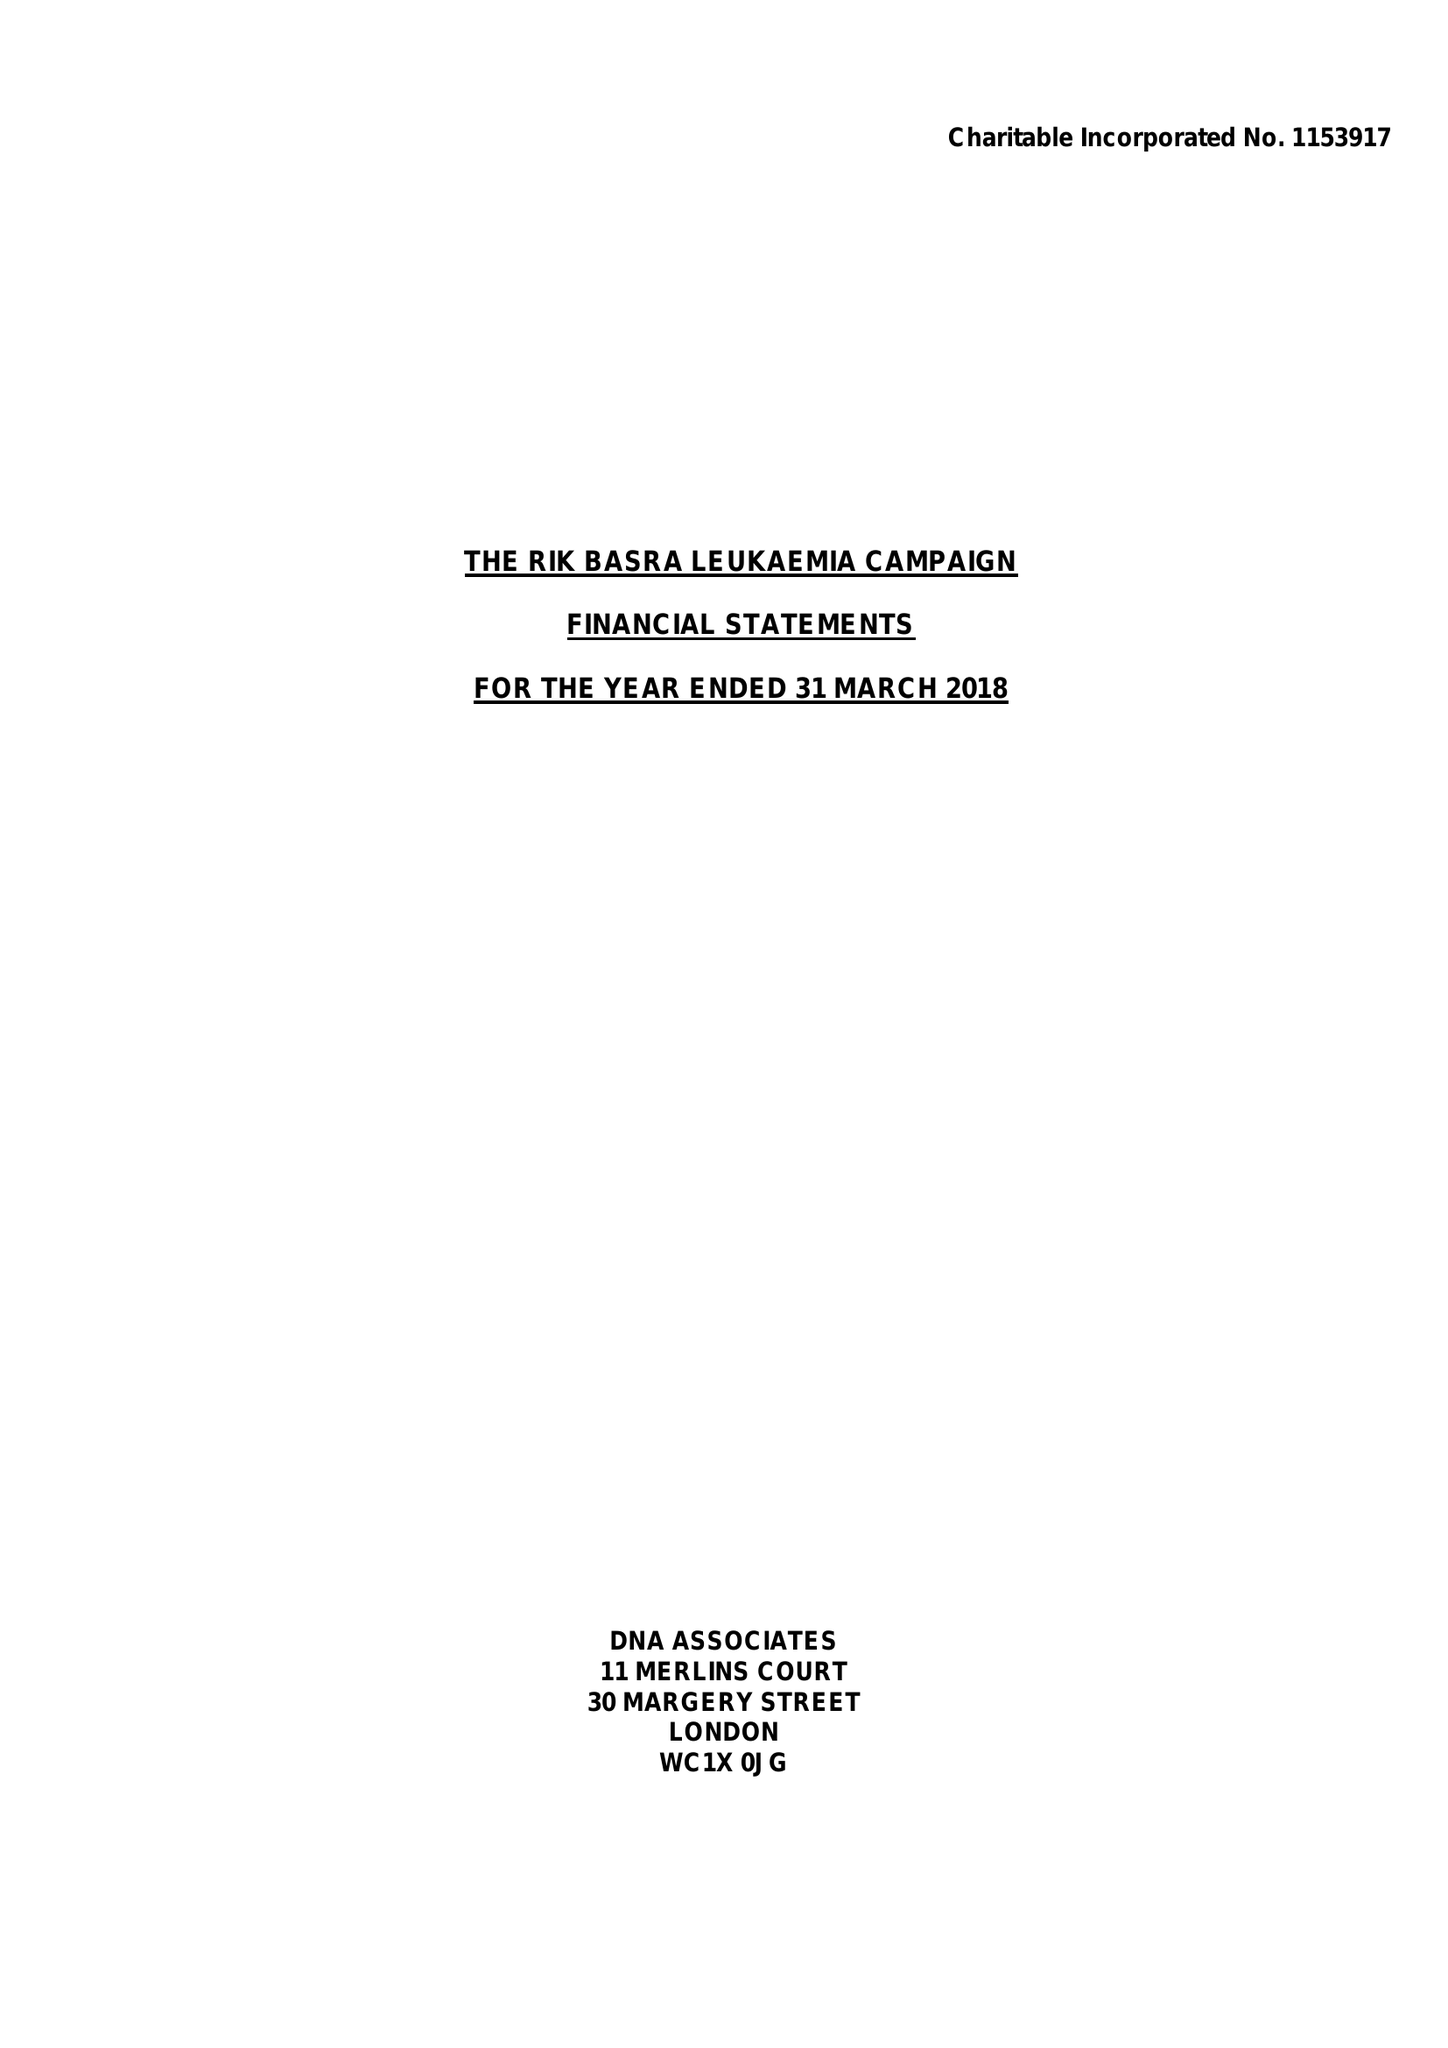What is the value for the spending_annually_in_british_pounds?
Answer the question using a single word or phrase. 15806.00 